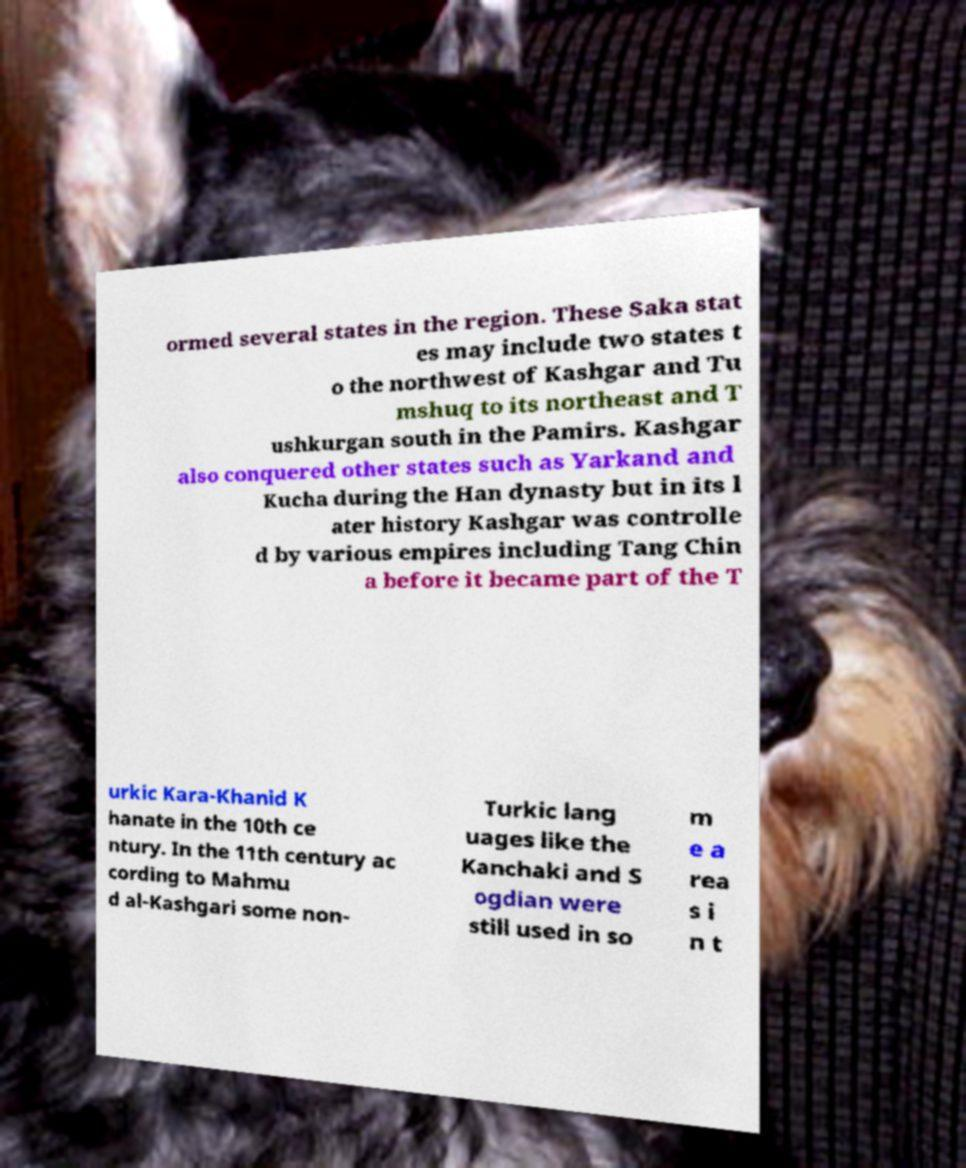There's text embedded in this image that I need extracted. Can you transcribe it verbatim? ormed several states in the region. These Saka stat es may include two states t o the northwest of Kashgar and Tu mshuq to its northeast and T ushkurgan south in the Pamirs. Kashgar also conquered other states such as Yarkand and Kucha during the Han dynasty but in its l ater history Kashgar was controlle d by various empires including Tang Chin a before it became part of the T urkic Kara-Khanid K hanate in the 10th ce ntury. In the 11th century ac cording to Mahmu d al-Kashgari some non- Turkic lang uages like the Kanchaki and S ogdian were still used in so m e a rea s i n t 